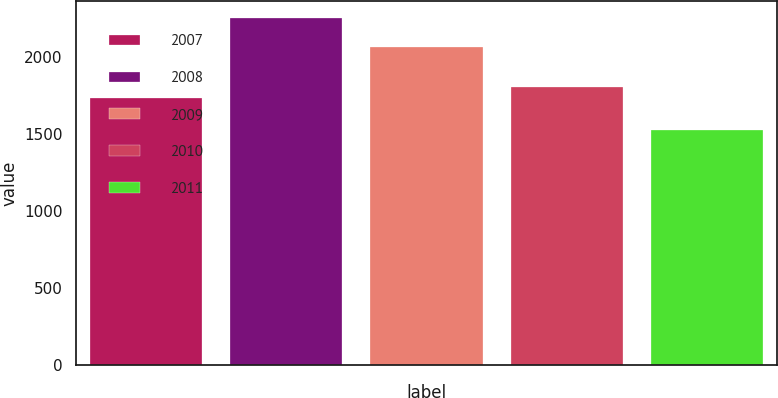Convert chart. <chart><loc_0><loc_0><loc_500><loc_500><bar_chart><fcel>2007<fcel>2008<fcel>2009<fcel>2010<fcel>2011<nl><fcel>1738<fcel>2256<fcel>2071<fcel>1810.9<fcel>1527<nl></chart> 